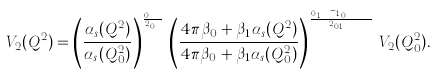Convert formula to latex. <formula><loc_0><loc_0><loc_500><loc_500>V _ { 2 } ( Q ^ { 2 } ) = \left ( \frac { \alpha _ { s } ( Q ^ { 2 } ) } { \alpha _ { s } ( Q _ { 0 } ^ { 2 } ) } \right ) ^ { \frac { \gamma _ { 0 } ^ { N S } } { 2 \beta _ { 0 } } } \, \left ( \frac { 4 \pi \beta _ { 0 } + \beta _ { 1 } \alpha _ { s } ( Q ^ { 2 } ) } { 4 \pi \beta _ { 0 } + \beta _ { 1 } \alpha _ { s } ( Q _ { 0 } ^ { 2 } ) } \right ) ^ { \frac { \beta _ { 0 } \gamma _ { 1 } ^ { N S } - \beta _ { 1 } \gamma _ { 0 } ^ { N S } } { 2 \beta _ { 0 } \beta _ { 1 } } } \, V _ { 2 } ( Q _ { 0 } ^ { 2 } ) .</formula> 